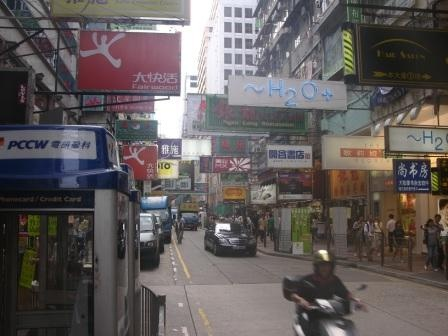Describe the objects in this image and their specific colors. I can see people in black and gray tones, car in black, gray, darkgray, and white tones, people in black, gray, and darkgreen tones, motorcycle in black, gray, darkgray, and lightgray tones, and truck in black, gray, and darkgray tones in this image. 